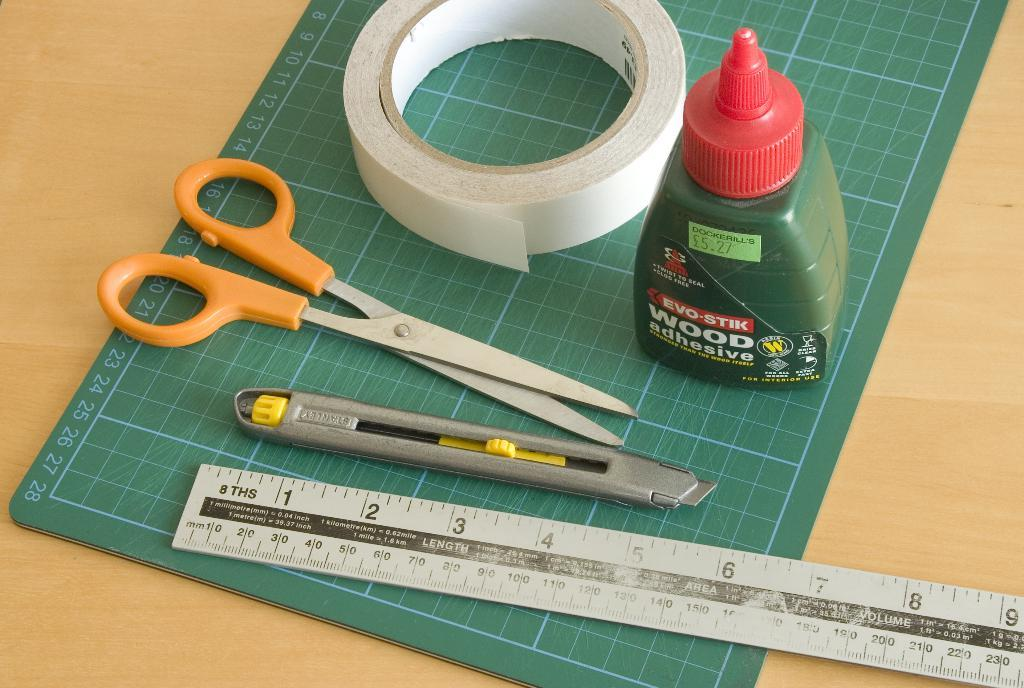<image>
Write a terse but informative summary of the picture. A bottle of Evo-Stik wood adhesive sits atop a green surface, along with other tools. 